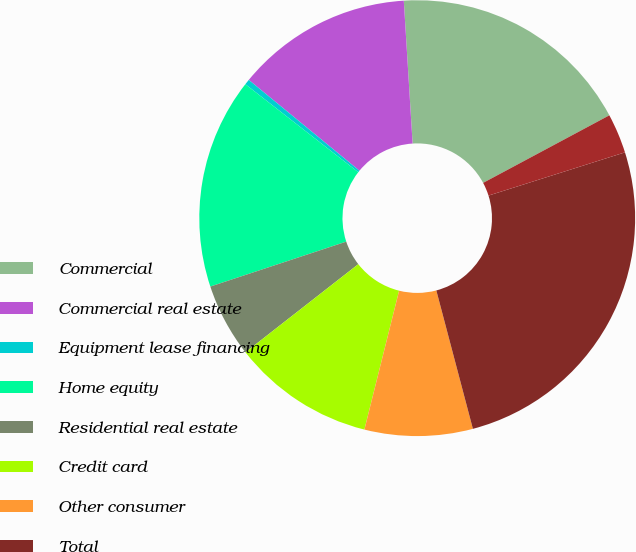<chart> <loc_0><loc_0><loc_500><loc_500><pie_chart><fcel>Commercial<fcel>Commercial real estate<fcel>Equipment lease financing<fcel>Home equity<fcel>Residential real estate<fcel>Credit card<fcel>Other consumer<fcel>Total<fcel>financing<nl><fcel>18.16%<fcel>13.08%<fcel>0.4%<fcel>15.62%<fcel>5.47%<fcel>10.55%<fcel>8.01%<fcel>25.77%<fcel>2.94%<nl></chart> 